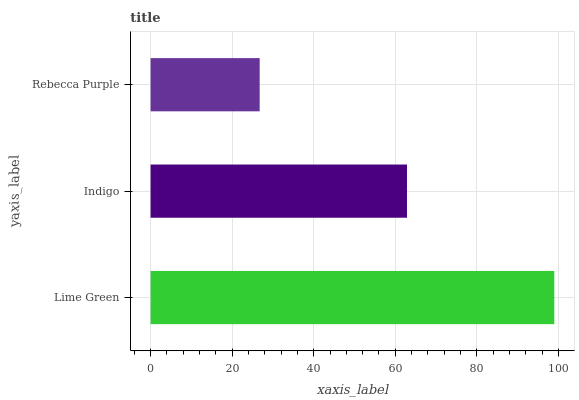Is Rebecca Purple the minimum?
Answer yes or no. Yes. Is Lime Green the maximum?
Answer yes or no. Yes. Is Indigo the minimum?
Answer yes or no. No. Is Indigo the maximum?
Answer yes or no. No. Is Lime Green greater than Indigo?
Answer yes or no. Yes. Is Indigo less than Lime Green?
Answer yes or no. Yes. Is Indigo greater than Lime Green?
Answer yes or no. No. Is Lime Green less than Indigo?
Answer yes or no. No. Is Indigo the high median?
Answer yes or no. Yes. Is Indigo the low median?
Answer yes or no. Yes. Is Lime Green the high median?
Answer yes or no. No. Is Lime Green the low median?
Answer yes or no. No. 